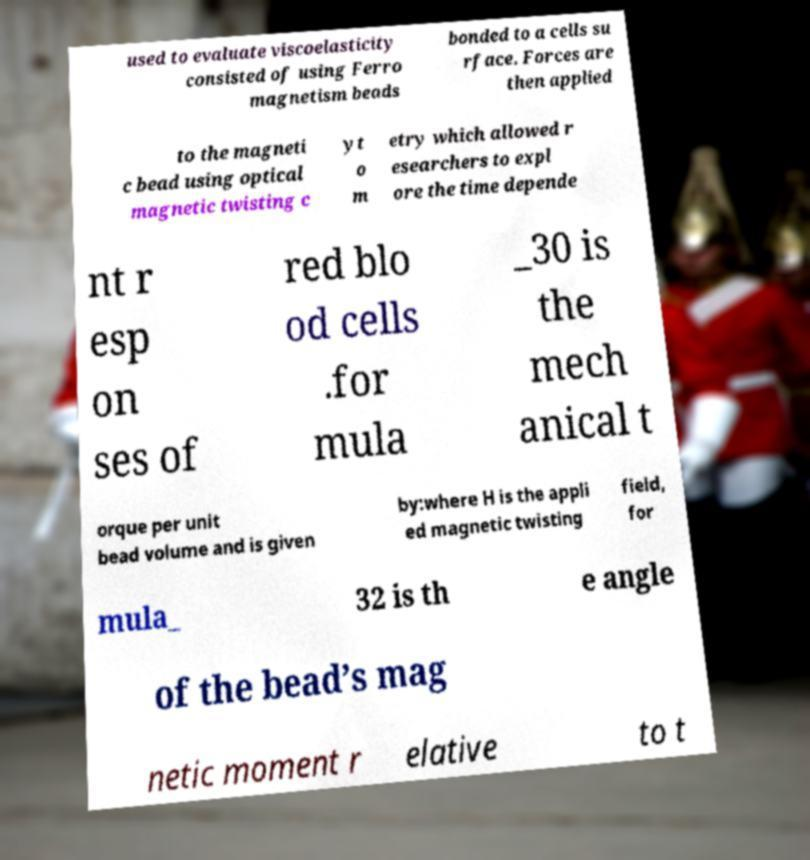Can you accurately transcribe the text from the provided image for me? used to evaluate viscoelasticity consisted of using Ferro magnetism beads bonded to a cells su rface. Forces are then applied to the magneti c bead using optical magnetic twisting c yt o m etry which allowed r esearchers to expl ore the time depende nt r esp on ses of red blo od cells .for mula _30 is the mech anical t orque per unit bead volume and is given by:where H is the appli ed magnetic twisting field, for mula_ 32 is th e angle of the bead’s mag netic moment r elative to t 